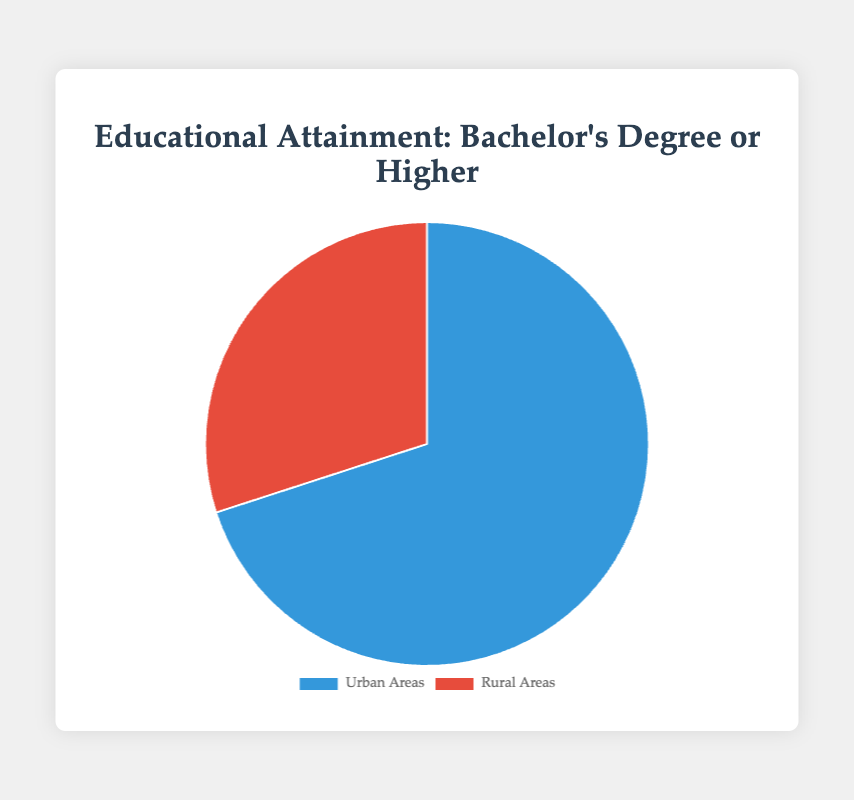What is the percentage of Bachelor's degree or higher in Urban Areas? Urban Areas are represented by a section of the pie chart labeled "Urban Areas" with a corresponding percentage.
Answer: 35% What is the percentage of Bachelor's degree or higher in Rural Areas? Rural Areas are represented by a section of the pie chart labeled "Rural Areas" with a corresponding percentage.
Answer: 15% Which area has a higher percentage of residents with a Bachelor's degree or higher? By comparing the two sections of the pie chart, Urban Areas have a larger percentage (35%) compared to Rural Areas (15%).
Answer: Urban Areas What is the difference in the percentage of Bachelor's degree or higher between Urban and Rural Areas? The percentage for Urban Areas is 35%, and for Rural Areas, it's 15%. The difference is 35% - 15%.
Answer: 20% What is the total percentage represented in the pie chart? The pie chart represents the whole population, so the total percentage is 100%. The two sectors combined (35% for Urban and 15% for Rural) should sum up to a part of the whole.
Answer: 100% How much larger in terms of percentage is the Urban Areas' section compared to the Rural Areas' section? The Urban Areas' section is 35%, and the Rural Areas' section is 15%. The percentage difference is calculated as (35% - 15%) / 15% * 100%.
Answer: 133.33% If we were to convert this pie chart to a bar chart, how would the heights of the bars compare between Urban and Rural Areas? The height of the bars would reflect the percentages, with Urban Areas having a bar height of 35 units and Rural Areas having a bar height of 15 units. Urban's bar height would be more than double the height of Rural's bar.
Answer: Urban: 35 units, Rural: 15 units 